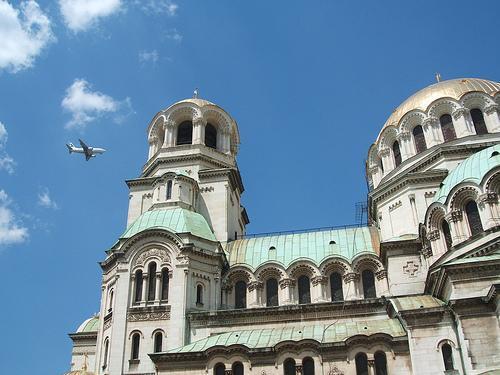How many planes are in the photo?
Give a very brief answer. 1. How many domes are shown on the building?
Give a very brief answer. 2. How many people are pictured here?
Give a very brief answer. 0. 